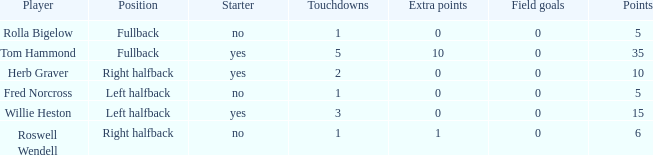Write the full table. {'header': ['Player', 'Position', 'Starter', 'Touchdowns', 'Extra points', 'Field goals', 'Points'], 'rows': [['Rolla Bigelow', 'Fullback', 'no', '1', '0', '0', '5'], ['Tom Hammond', 'Fullback', 'yes', '5', '10', '0', '35'], ['Herb Graver', 'Right halfback', 'yes', '2', '0', '0', '10'], ['Fred Norcross', 'Left halfback', 'no', '1', '0', '0', '5'], ['Willie Heston', 'Left halfback', 'yes', '3', '0', '0', '15'], ['Roswell Wendell', 'Right halfback', 'no', '1', '1', '0', '6']]} What is the lowest number of field goals for a player with 3 touchdowns? 0.0. 